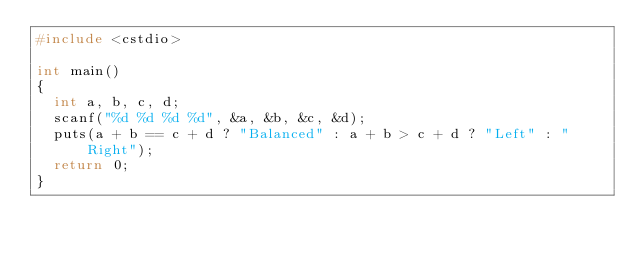Convert code to text. <code><loc_0><loc_0><loc_500><loc_500><_C++_>#include <cstdio>

int main()
{
  int a, b, c, d;
  scanf("%d %d %d %d", &a, &b, &c, &d);
  puts(a + b == c + d ? "Balanced" : a + b > c + d ? "Left" : "Right");
  return 0;
}</code> 